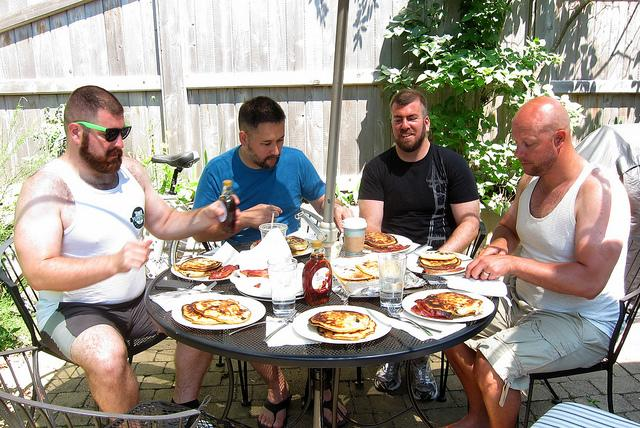What food on the table has the highest level of fat? bacon 